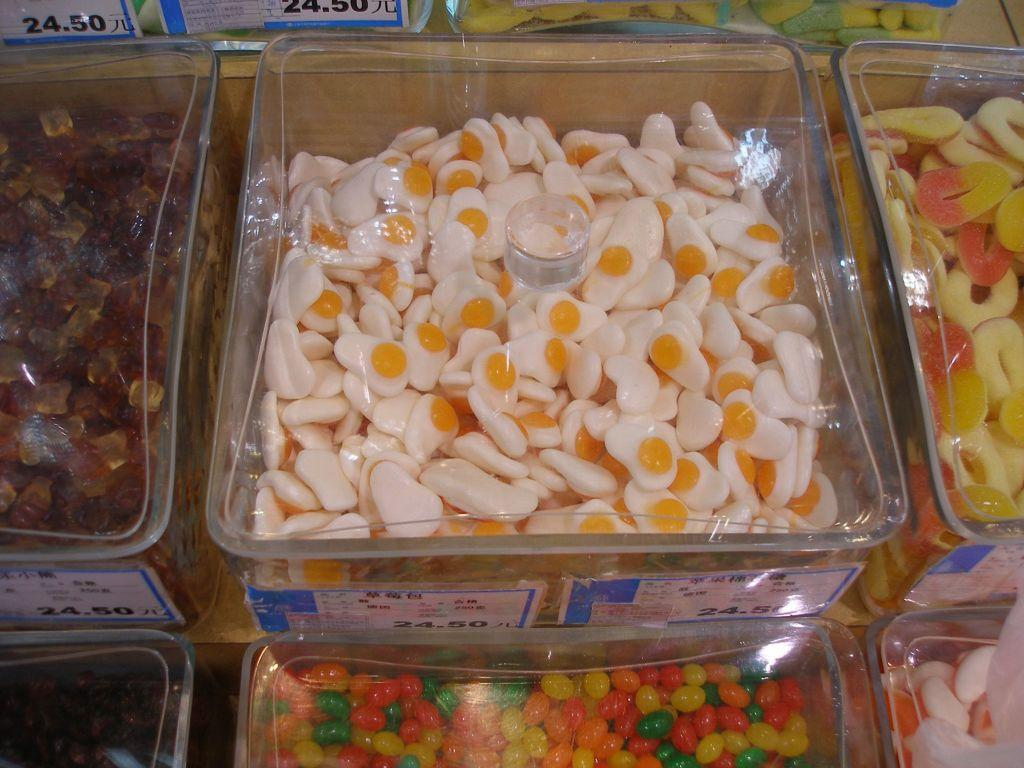What type of containers are present in the image? There are glass boxes in the image. What is inside the glass boxes? There are candies in the glass boxes. What else can be seen in the image besides the glass boxes? There are boards in the image. What is written or displayed on the boards? There is text on the boards. Can you see any bushes or plants near the seashore in the image? There is no seashore or bushes present in the image; it features glass boxes with candies and boards with text. 